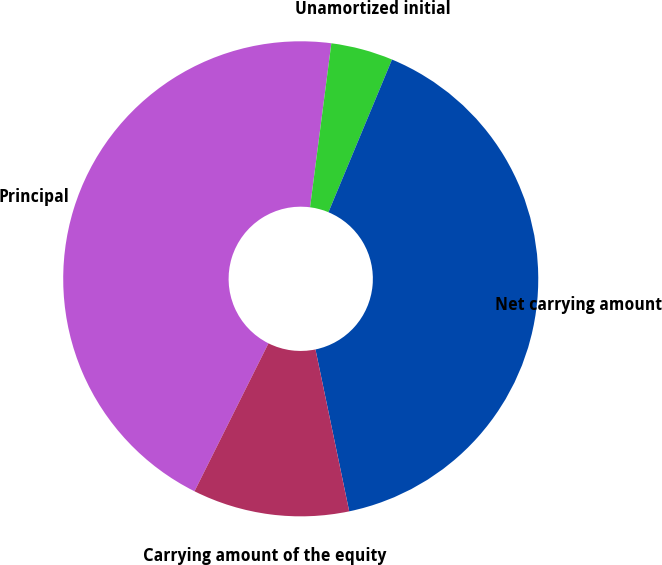Convert chart. <chart><loc_0><loc_0><loc_500><loc_500><pie_chart><fcel>Principal<fcel>Unamortized initial<fcel>Net carrying amount<fcel>Carrying amount of the equity<nl><fcel>44.68%<fcel>4.22%<fcel>40.45%<fcel>10.65%<nl></chart> 